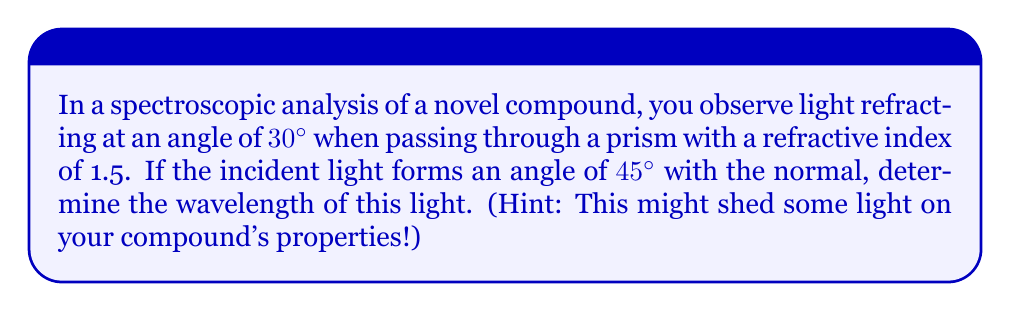Could you help me with this problem? Let's approach this step-by-step:

1) First, recall Snell's law:
   $$n_1 \sin \theta_1 = n_2 \sin \theta_2$$
   where $n_1$ and $n_2$ are the refractive indices, and $\theta_1$ and $\theta_2$ are the angles of incidence and refraction respectively.

2) We're given:
   - $n_1 = 1$ (air)
   - $n_2 = 1.5$ (prism)
   - $\theta_2 = 30°$ (angle of refraction)
   - $\theta_1 = 45°$ (angle of incidence)

3) Let's substitute these into Snell's law:
   $$1 \cdot \sin 45° = 1.5 \cdot \sin 30°$$

4) Simplify:
   $$\frac{\sqrt{2}}{2} = 1.5 \cdot \frac{1}{2}$$

5) This equation is true, confirming our given information.

6) Now, to find the wavelength, we can use the grating equation:
   $$d \sin \theta = m\lambda$$
   where $d$ is the grating spacing, $\theta$ is the angle of diffraction (in our case, the angle of refraction), $m$ is the order of diffraction (let's assume 1st order), and $\lambda$ is the wavelength.

7) We don't know $d$, but we can find it using the refractive index formula:
   $$n = \frac{c}{v} = \frac{\lambda_0}{\lambda}$$
   where $\lambda_0$ is the wavelength in vacuum and $\lambda$ is the wavelength in the medium.

8) Rearranging this:
   $$d = \lambda_0 = n\lambda = 1.5\lambda$$

9) Substituting this into the grating equation:
   $$1.5\lambda \sin 30° = 1\lambda$$

10) Solving for $\lambda$:
    $$\lambda = \frac{1}{1.5 \sin 30°} = \frac{2}{1.5} = \frac{4}{3} \approx 1.33$$

11) Therefore, the wavelength is approximately 1.33 units (likely micrometers or nanometers, depending on the scale of your spectroscopic analysis).
Answer: $\lambda \approx 1.33$ units 